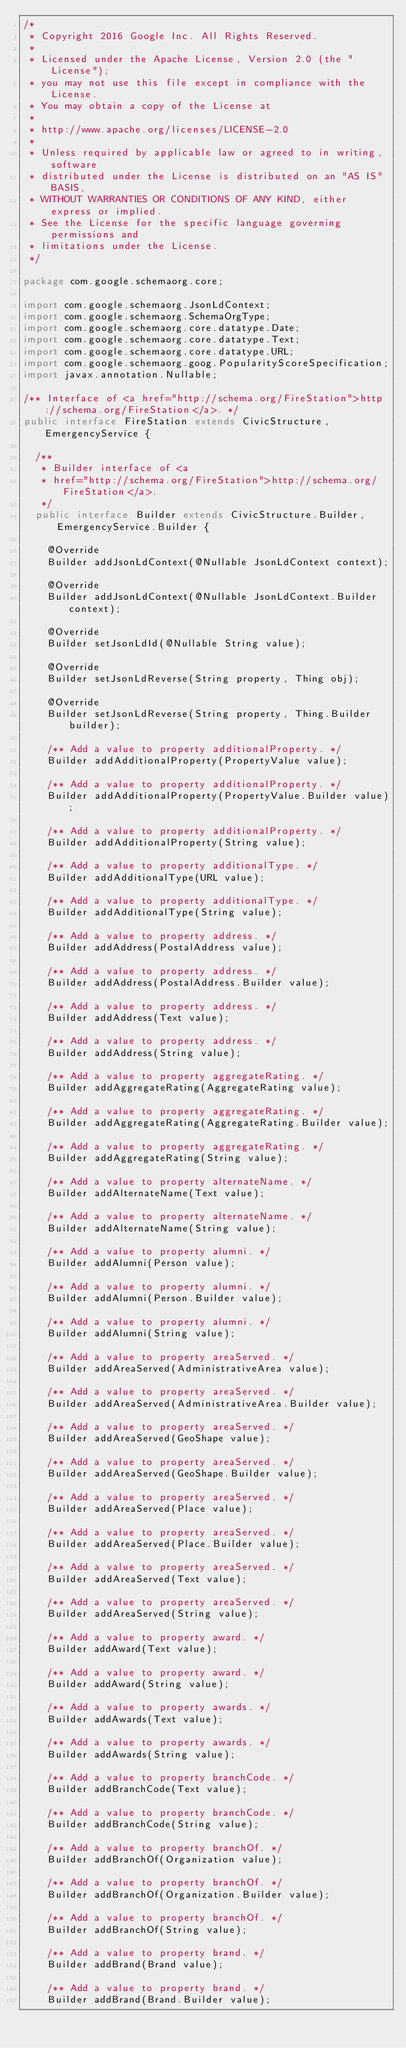<code> <loc_0><loc_0><loc_500><loc_500><_Java_>/*
 * Copyright 2016 Google Inc. All Rights Reserved.
 *
 * Licensed under the Apache License, Version 2.0 (the "License");
 * you may not use this file except in compliance with the License.
 * You may obtain a copy of the License at
 *
 * http://www.apache.org/licenses/LICENSE-2.0
 *
 * Unless required by applicable law or agreed to in writing, software
 * distributed under the License is distributed on an "AS IS" BASIS,
 * WITHOUT WARRANTIES OR CONDITIONS OF ANY KIND, either express or implied.
 * See the License for the specific language governing permissions and
 * limitations under the License.
 */

package com.google.schemaorg.core;

import com.google.schemaorg.JsonLdContext;
import com.google.schemaorg.SchemaOrgType;
import com.google.schemaorg.core.datatype.Date;
import com.google.schemaorg.core.datatype.Text;
import com.google.schemaorg.core.datatype.URL;
import com.google.schemaorg.goog.PopularityScoreSpecification;
import javax.annotation.Nullable;

/** Interface of <a href="http://schema.org/FireStation">http://schema.org/FireStation</a>. */
public interface FireStation extends CivicStructure, EmergencyService {

  /**
   * Builder interface of <a
   * href="http://schema.org/FireStation">http://schema.org/FireStation</a>.
   */
  public interface Builder extends CivicStructure.Builder, EmergencyService.Builder {

    @Override
    Builder addJsonLdContext(@Nullable JsonLdContext context);

    @Override
    Builder addJsonLdContext(@Nullable JsonLdContext.Builder context);

    @Override
    Builder setJsonLdId(@Nullable String value);

    @Override
    Builder setJsonLdReverse(String property, Thing obj);

    @Override
    Builder setJsonLdReverse(String property, Thing.Builder builder);

    /** Add a value to property additionalProperty. */
    Builder addAdditionalProperty(PropertyValue value);

    /** Add a value to property additionalProperty. */
    Builder addAdditionalProperty(PropertyValue.Builder value);

    /** Add a value to property additionalProperty. */
    Builder addAdditionalProperty(String value);

    /** Add a value to property additionalType. */
    Builder addAdditionalType(URL value);

    /** Add a value to property additionalType. */
    Builder addAdditionalType(String value);

    /** Add a value to property address. */
    Builder addAddress(PostalAddress value);

    /** Add a value to property address. */
    Builder addAddress(PostalAddress.Builder value);

    /** Add a value to property address. */
    Builder addAddress(Text value);

    /** Add a value to property address. */
    Builder addAddress(String value);

    /** Add a value to property aggregateRating. */
    Builder addAggregateRating(AggregateRating value);

    /** Add a value to property aggregateRating. */
    Builder addAggregateRating(AggregateRating.Builder value);

    /** Add a value to property aggregateRating. */
    Builder addAggregateRating(String value);

    /** Add a value to property alternateName. */
    Builder addAlternateName(Text value);

    /** Add a value to property alternateName. */
    Builder addAlternateName(String value);

    /** Add a value to property alumni. */
    Builder addAlumni(Person value);

    /** Add a value to property alumni. */
    Builder addAlumni(Person.Builder value);

    /** Add a value to property alumni. */
    Builder addAlumni(String value);

    /** Add a value to property areaServed. */
    Builder addAreaServed(AdministrativeArea value);

    /** Add a value to property areaServed. */
    Builder addAreaServed(AdministrativeArea.Builder value);

    /** Add a value to property areaServed. */
    Builder addAreaServed(GeoShape value);

    /** Add a value to property areaServed. */
    Builder addAreaServed(GeoShape.Builder value);

    /** Add a value to property areaServed. */
    Builder addAreaServed(Place value);

    /** Add a value to property areaServed. */
    Builder addAreaServed(Place.Builder value);

    /** Add a value to property areaServed. */
    Builder addAreaServed(Text value);

    /** Add a value to property areaServed. */
    Builder addAreaServed(String value);

    /** Add a value to property award. */
    Builder addAward(Text value);

    /** Add a value to property award. */
    Builder addAward(String value);

    /** Add a value to property awards. */
    Builder addAwards(Text value);

    /** Add a value to property awards. */
    Builder addAwards(String value);

    /** Add a value to property branchCode. */
    Builder addBranchCode(Text value);

    /** Add a value to property branchCode. */
    Builder addBranchCode(String value);

    /** Add a value to property branchOf. */
    Builder addBranchOf(Organization value);

    /** Add a value to property branchOf. */
    Builder addBranchOf(Organization.Builder value);

    /** Add a value to property branchOf. */
    Builder addBranchOf(String value);

    /** Add a value to property brand. */
    Builder addBrand(Brand value);

    /** Add a value to property brand. */
    Builder addBrand(Brand.Builder value);
</code> 